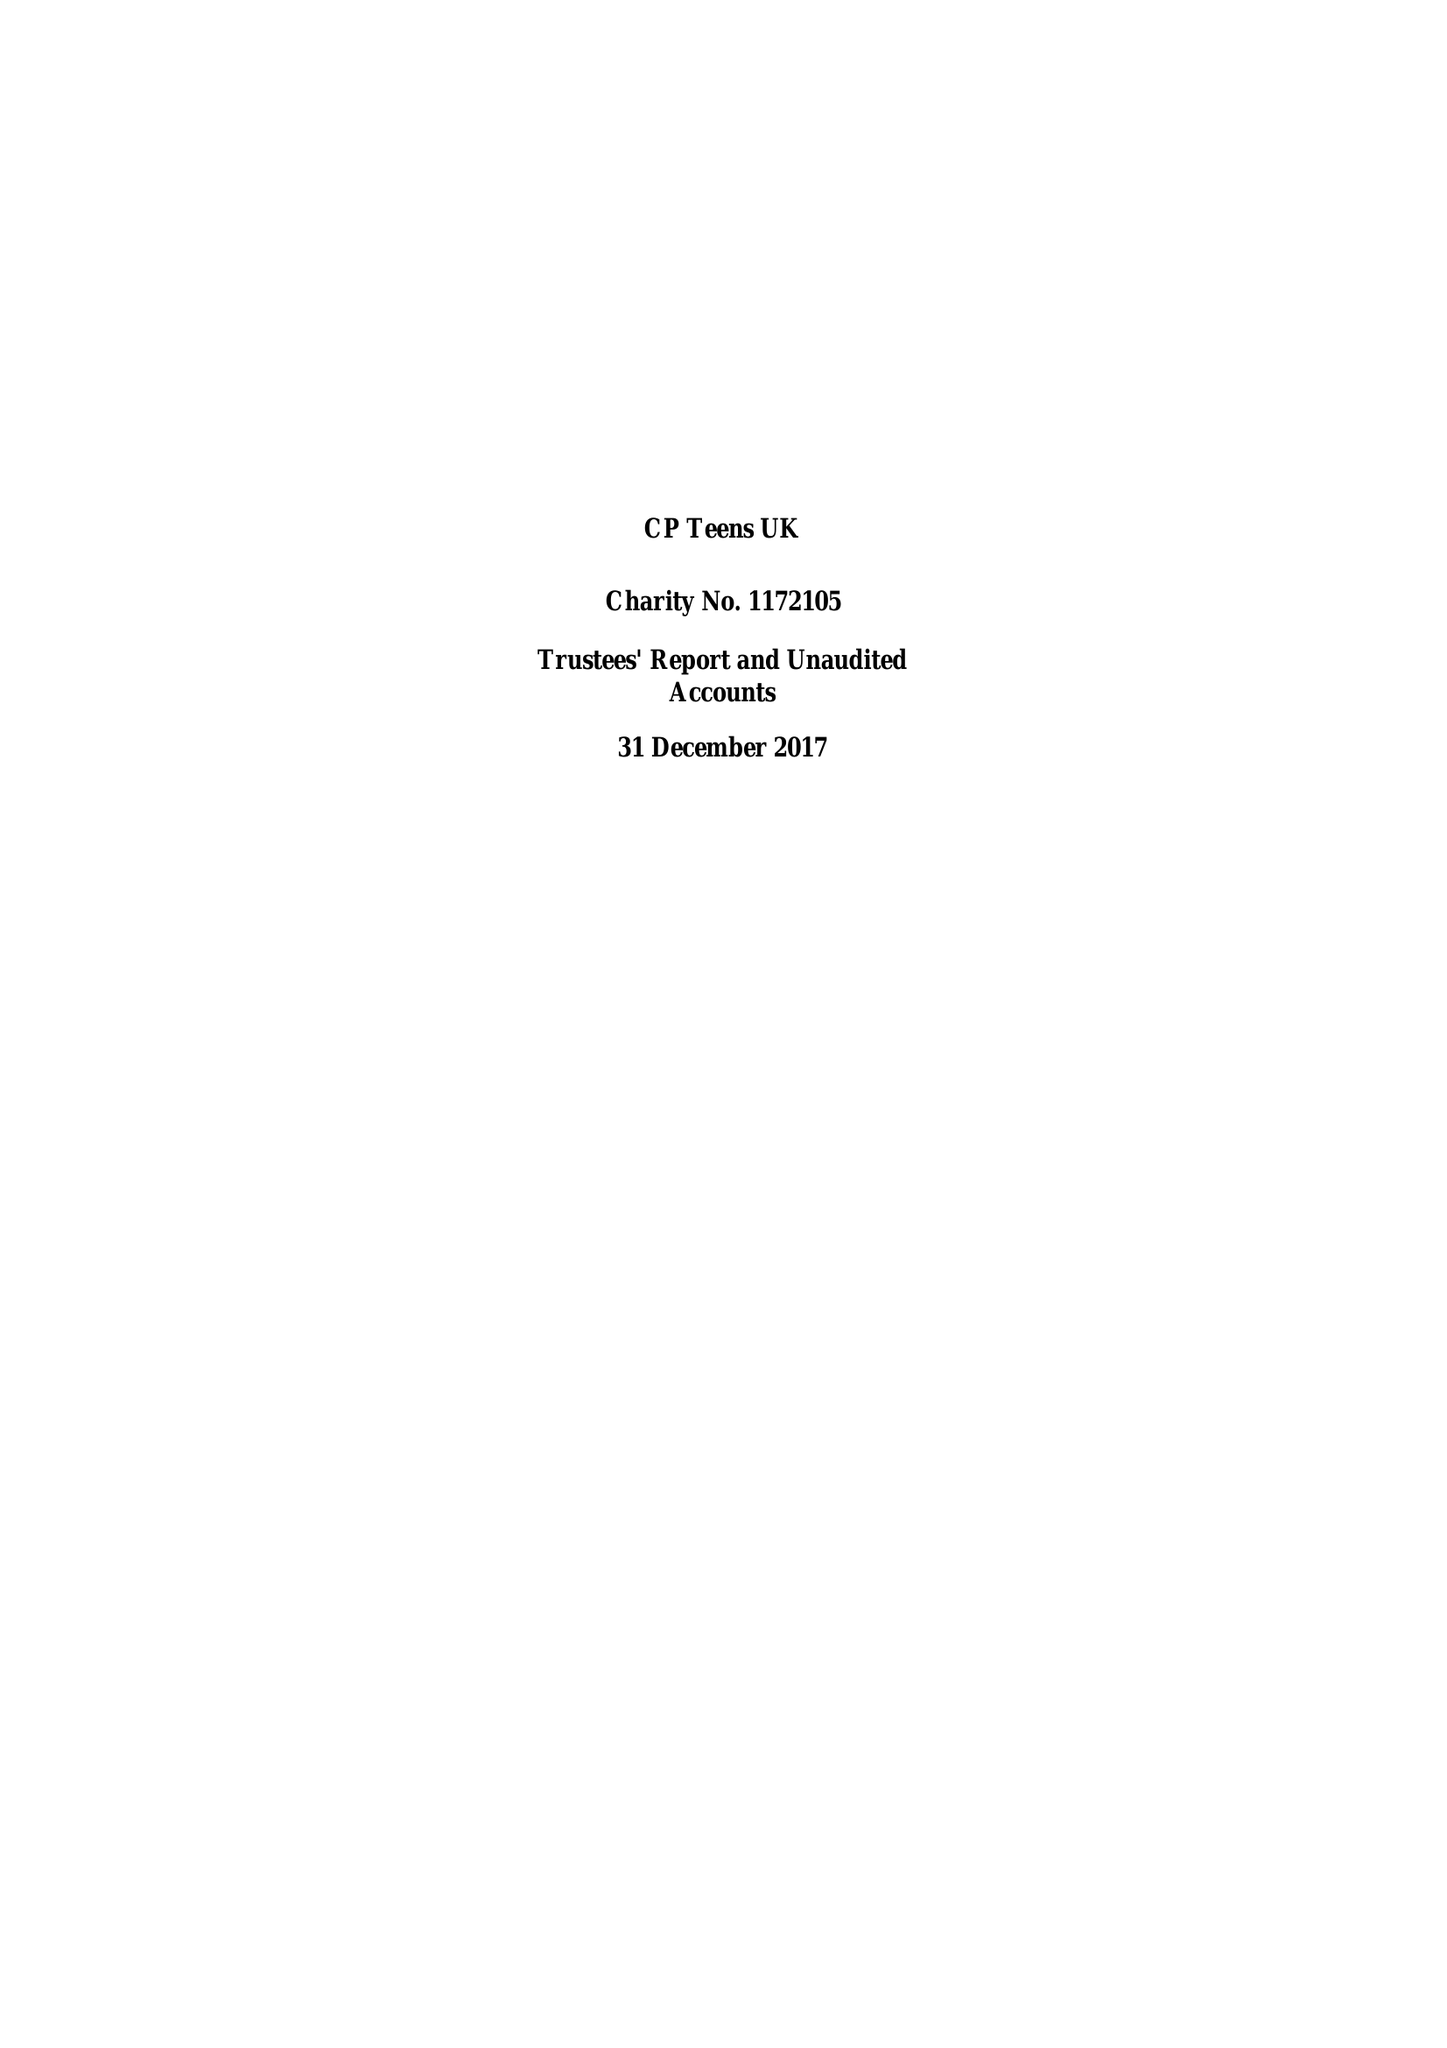What is the value for the spending_annually_in_british_pounds?
Answer the question using a single word or phrase. 10883.00 